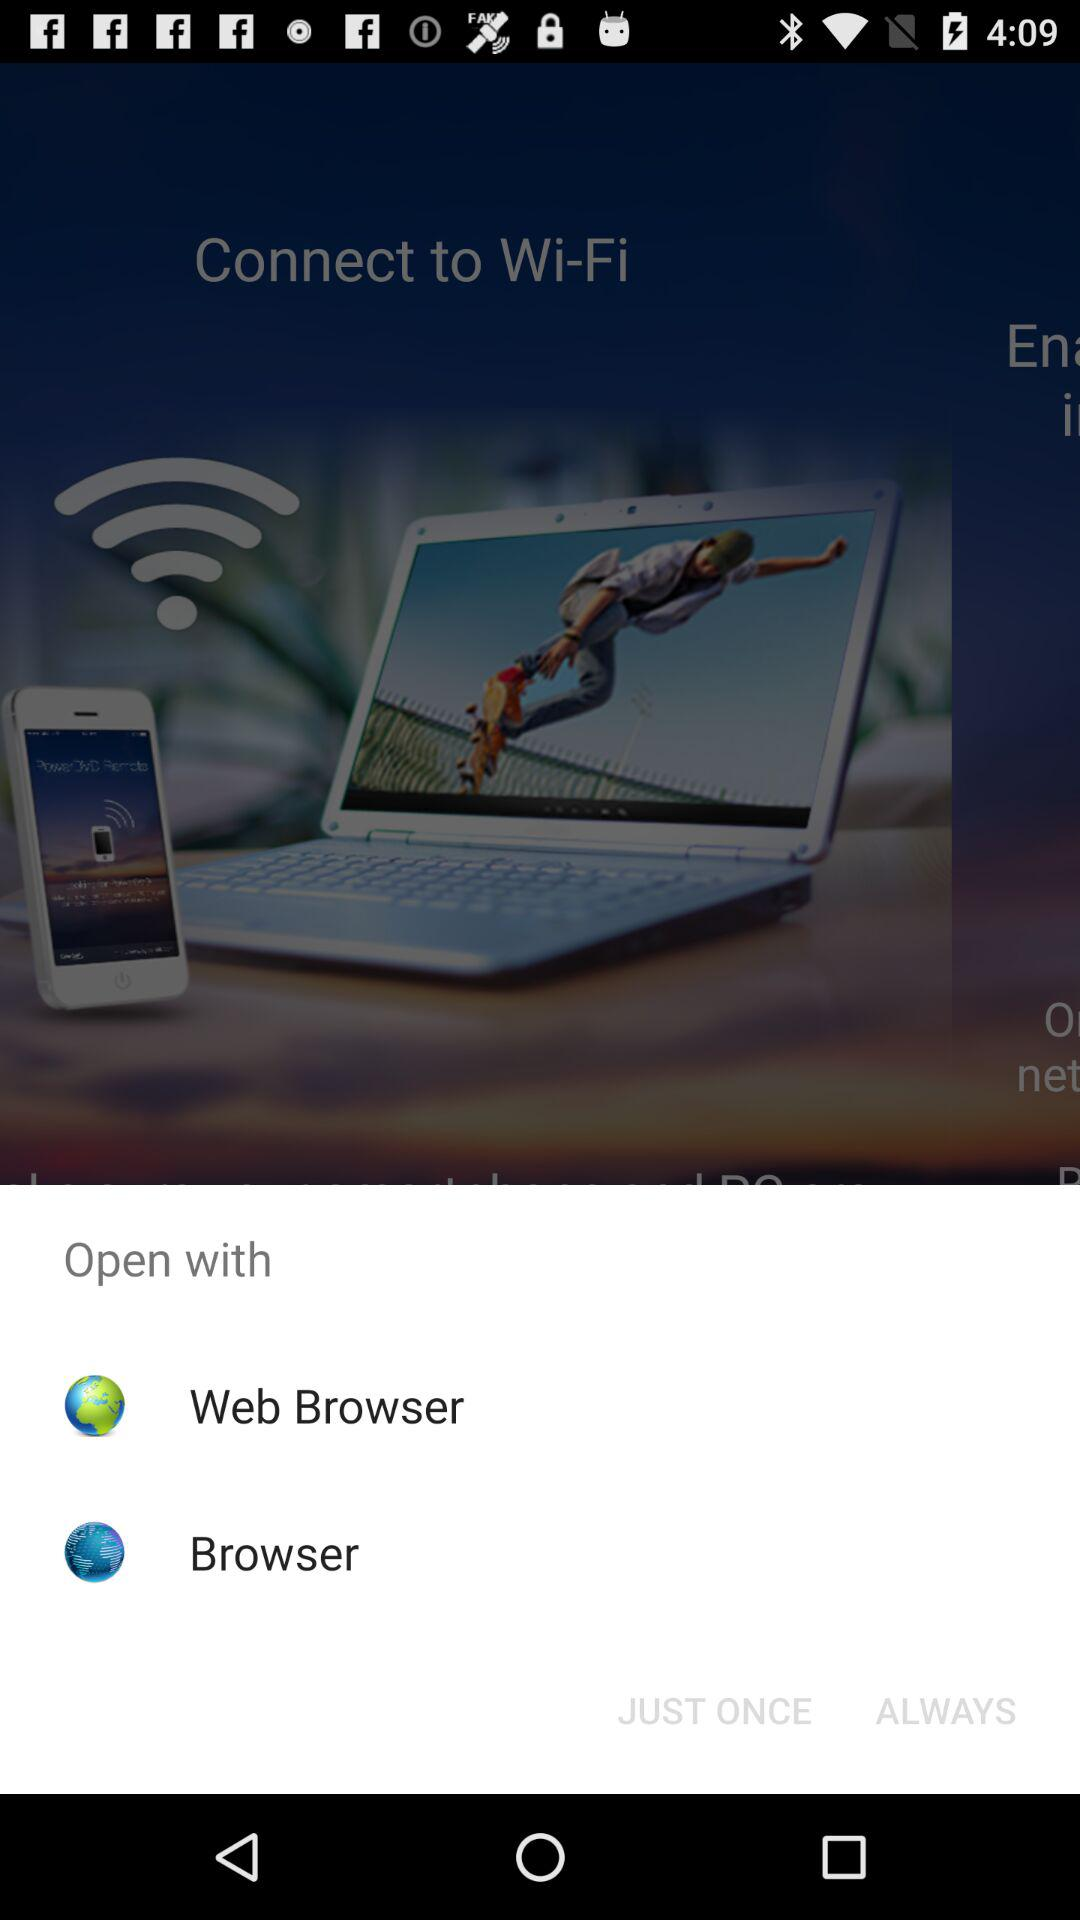What are the different options through which we can open? We can open it through a web browser and a browser. 